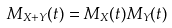Convert formula to latex. <formula><loc_0><loc_0><loc_500><loc_500>M _ { X + Y } ( t ) = M _ { X } ( t ) M _ { Y } ( t )</formula> 